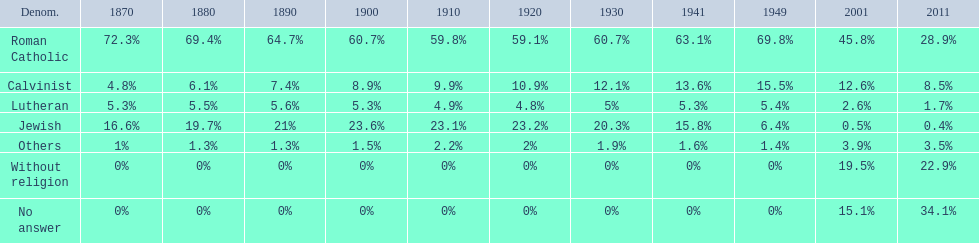What is the largest religious denomination in budapest? Roman Catholic. Parse the table in full. {'header': ['Denom.', '1870', '1880', '1890', '1900', '1910', '1920', '1930', '1941', '1949', '2001', '2011'], 'rows': [['Roman Catholic', '72.3%', '69.4%', '64.7%', '60.7%', '59.8%', '59.1%', '60.7%', '63.1%', '69.8%', '45.8%', '28.9%'], ['Calvinist', '4.8%', '6.1%', '7.4%', '8.9%', '9.9%', '10.9%', '12.1%', '13.6%', '15.5%', '12.6%', '8.5%'], ['Lutheran', '5.3%', '5.5%', '5.6%', '5.3%', '4.9%', '4.8%', '5%', '5.3%', '5.4%', '2.6%', '1.7%'], ['Jewish', '16.6%', '19.7%', '21%', '23.6%', '23.1%', '23.2%', '20.3%', '15.8%', '6.4%', '0.5%', '0.4%'], ['Others', '1%', '1.3%', '1.3%', '1.5%', '2.2%', '2%', '1.9%', '1.6%', '1.4%', '3.9%', '3.5%'], ['Without religion', '0%', '0%', '0%', '0%', '0%', '0%', '0%', '0%', '0%', '19.5%', '22.9%'], ['No answer', '0%', '0%', '0%', '0%', '0%', '0%', '0%', '0%', '0%', '15.1%', '34.1%']]} 